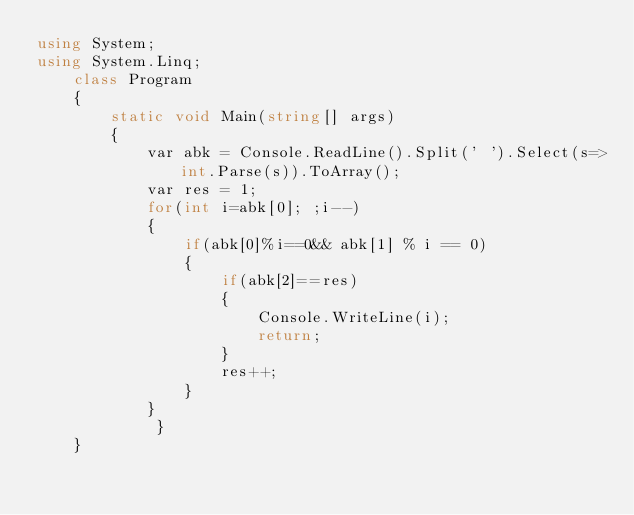<code> <loc_0><loc_0><loc_500><loc_500><_C#_>using System;
using System.Linq;
    class Program
    {
        static void Main(string[] args)
        {
            var abk = Console.ReadLine().Split(' ').Select(s=>int.Parse(s)).ToArray();
            var res = 1;
            for(int i=abk[0]; ;i--)
            {
                if(abk[0]%i==0&& abk[1] % i == 0)
                {
                    if(abk[2]==res)
                    {
                        Console.WriteLine(i);
                        return;
                    }
                    res++;
                }
            }
             }
    }</code> 